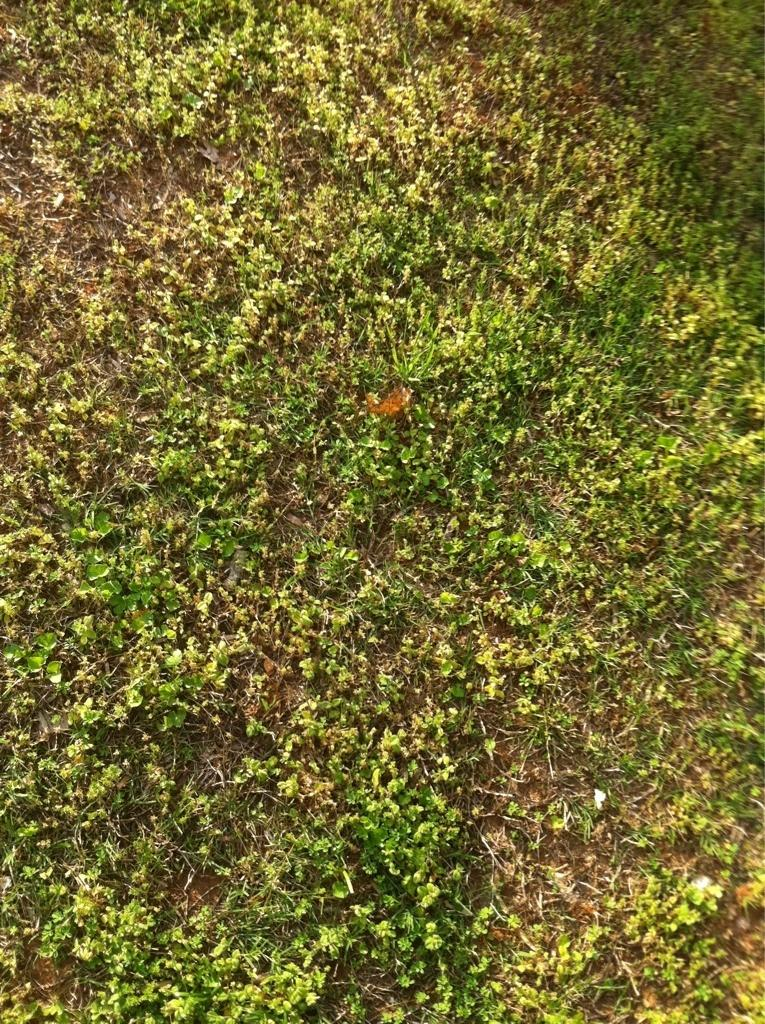What type of vegetation is present in the image? There is green-colored grass in the image. What is the color of the object in the image? The object in the image is orange-colored. Is the grass in the image actually quicksand? No, the grass in the image is not quicksand; it is green-colored grass. What type of seed is present in the image? There is no seed present in the image. 